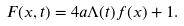Convert formula to latex. <formula><loc_0><loc_0><loc_500><loc_500>F ( x , t ) = 4 a \Lambda ( t ) f ( x ) + 1 .</formula> 